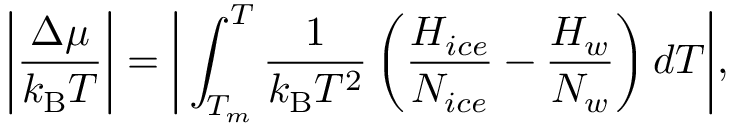<formula> <loc_0><loc_0><loc_500><loc_500>\left | \frac { \Delta \mu } { k _ { B } T } \right | = \left | \int _ { T _ { m } } ^ { T } \frac { 1 } { k _ { B } T ^ { 2 } } \left ( \frac { H _ { i c e } } { N _ { i c e } } - \frac { H _ { w } } { N _ { w } } \right ) d T \right | ,</formula> 